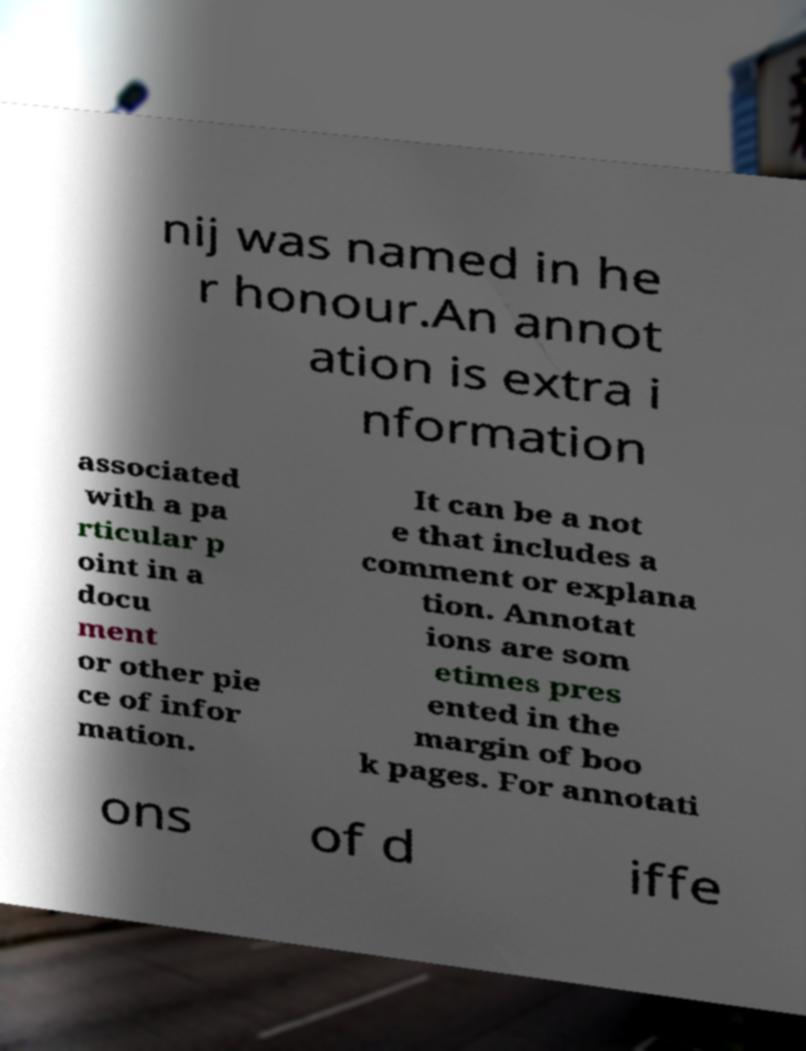Can you read and provide the text displayed in the image?This photo seems to have some interesting text. Can you extract and type it out for me? nij was named in he r honour.An annot ation is extra i nformation associated with a pa rticular p oint in a docu ment or other pie ce of infor mation. It can be a not e that includes a comment or explana tion. Annotat ions are som etimes pres ented in the margin of boo k pages. For annotati ons of d iffe 